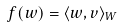Convert formula to latex. <formula><loc_0><loc_0><loc_500><loc_500>f ( w ) = \langle w , v \rangle _ { W }</formula> 